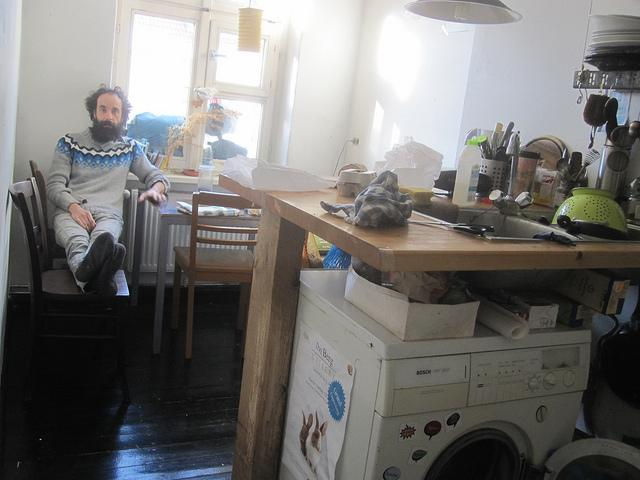What is the green object with holes in it called?

Choices:
A) colander
B) noodle maker
C) cheese grater
D) bowl colander 